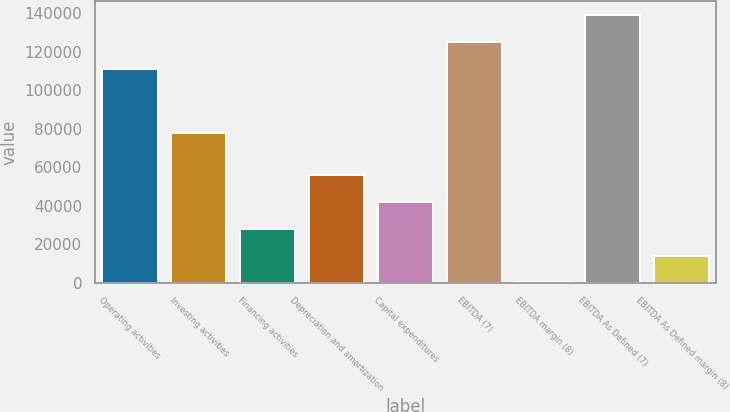Convert chart to OTSL. <chart><loc_0><loc_0><loc_500><loc_500><bar_chart><fcel>Operating activities<fcel>Investing activities<fcel>Financing activities<fcel>Depreciation and amortization<fcel>Capital expenditures<fcel>EBITDA (7)<fcel>EBITDA margin (8)<fcel>EBITDA As Defined (7)<fcel>EBITDA As Defined margin (8)<nl><fcel>111139<fcel>77619<fcel>27847<fcel>55656.2<fcel>41751.6<fcel>125044<fcel>37.7<fcel>139084<fcel>13942.3<nl></chart> 